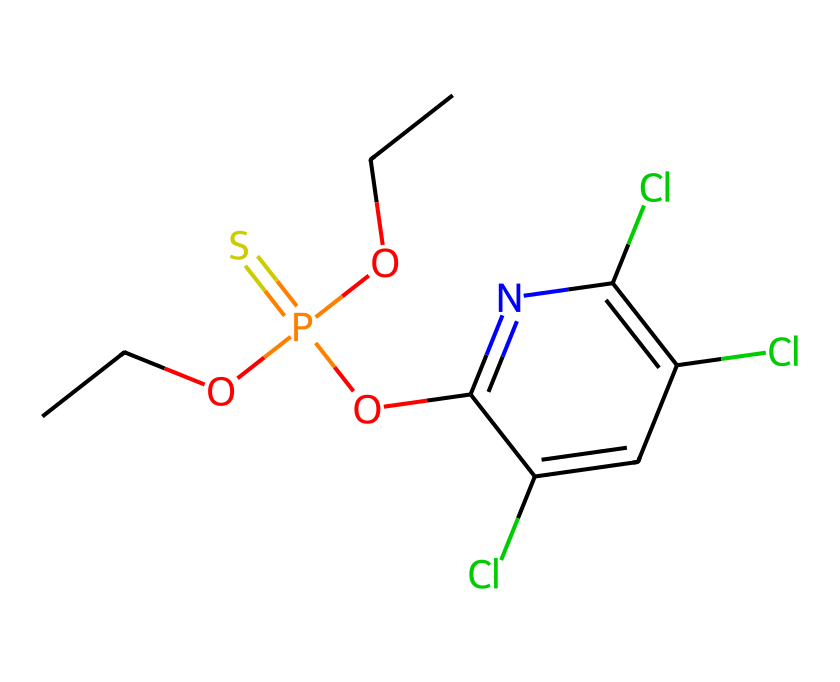What is the molecular formula of chlorpyrifos? To find the molecular formula, count the number of each type of atom in the SMILES. From the structure, we identify 10 Carbon (C), 10 Hydrogen (H), 4 Chlorine (Cl), 1 Phosphorus (P), and 1 Oxygen (O) atom. Thus, the molecular formula is C10H10Cl3NOP.
Answer: C10H10Cl3NOP How many chlorine atoms are present in chlorpyrifos? By examining the SMILES representation, we see the presence of three chlorine (Cl) symbols. Each 'Cl' corresponds to a chlorine atom in the structure.
Answer: three What is the role of the phosphorus atom in chlorpyrifos? The phosphorus atom is integral to the molecular structure and contributes to the compound's function as a pesticide by enabling its interaction with acetylcholinesterase, which is critical for nerve signal transmission in pests.
Answer: pesticide action How does chlorpyrifos affect biological systems? Chlorpyrifos disrupts acetylcholine metabolism by inhibiting the enzyme acetylcholinesterase, leading to an accumulation of acetylcholine, which causes overstimulation of the nervous system in insects and other organisms.
Answer: enzyme inhibition What type of pesticide is chlorpyrifos categorized as? Chlorpyrifos is categorized as an organophosphate pesticide, which is characterized by the presence of phosphorus and is commonly used for pest control.
Answer: organophosphate 